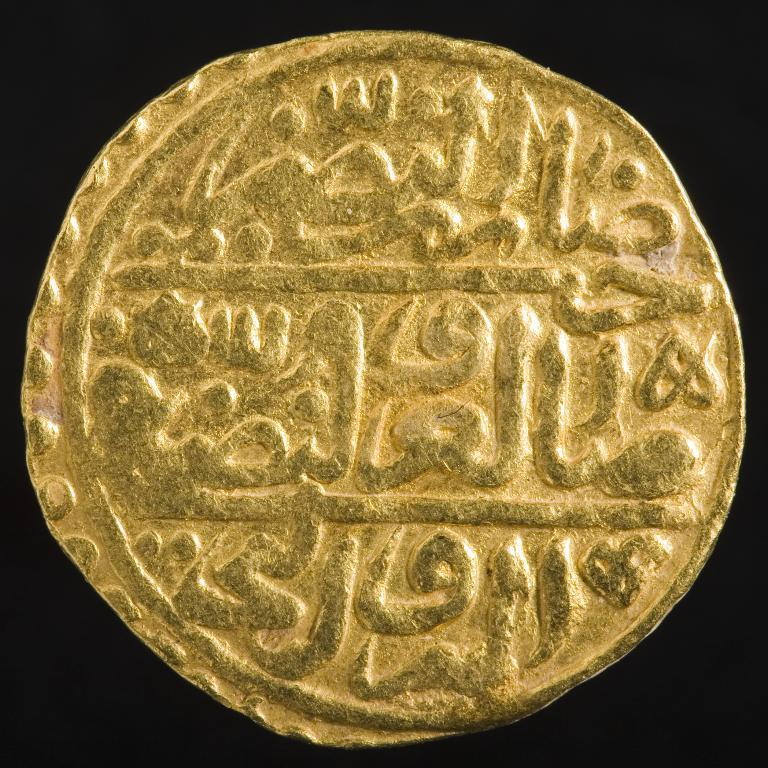What is the color of the main object in the image? The main object in the image is gold-colored. What can be seen on the surface of the object? The object has carved text on it. What color is the background of the image? The background of the image is black. How many apples are sitting on the coach in the image? There are no apples or coaches present in the image. 